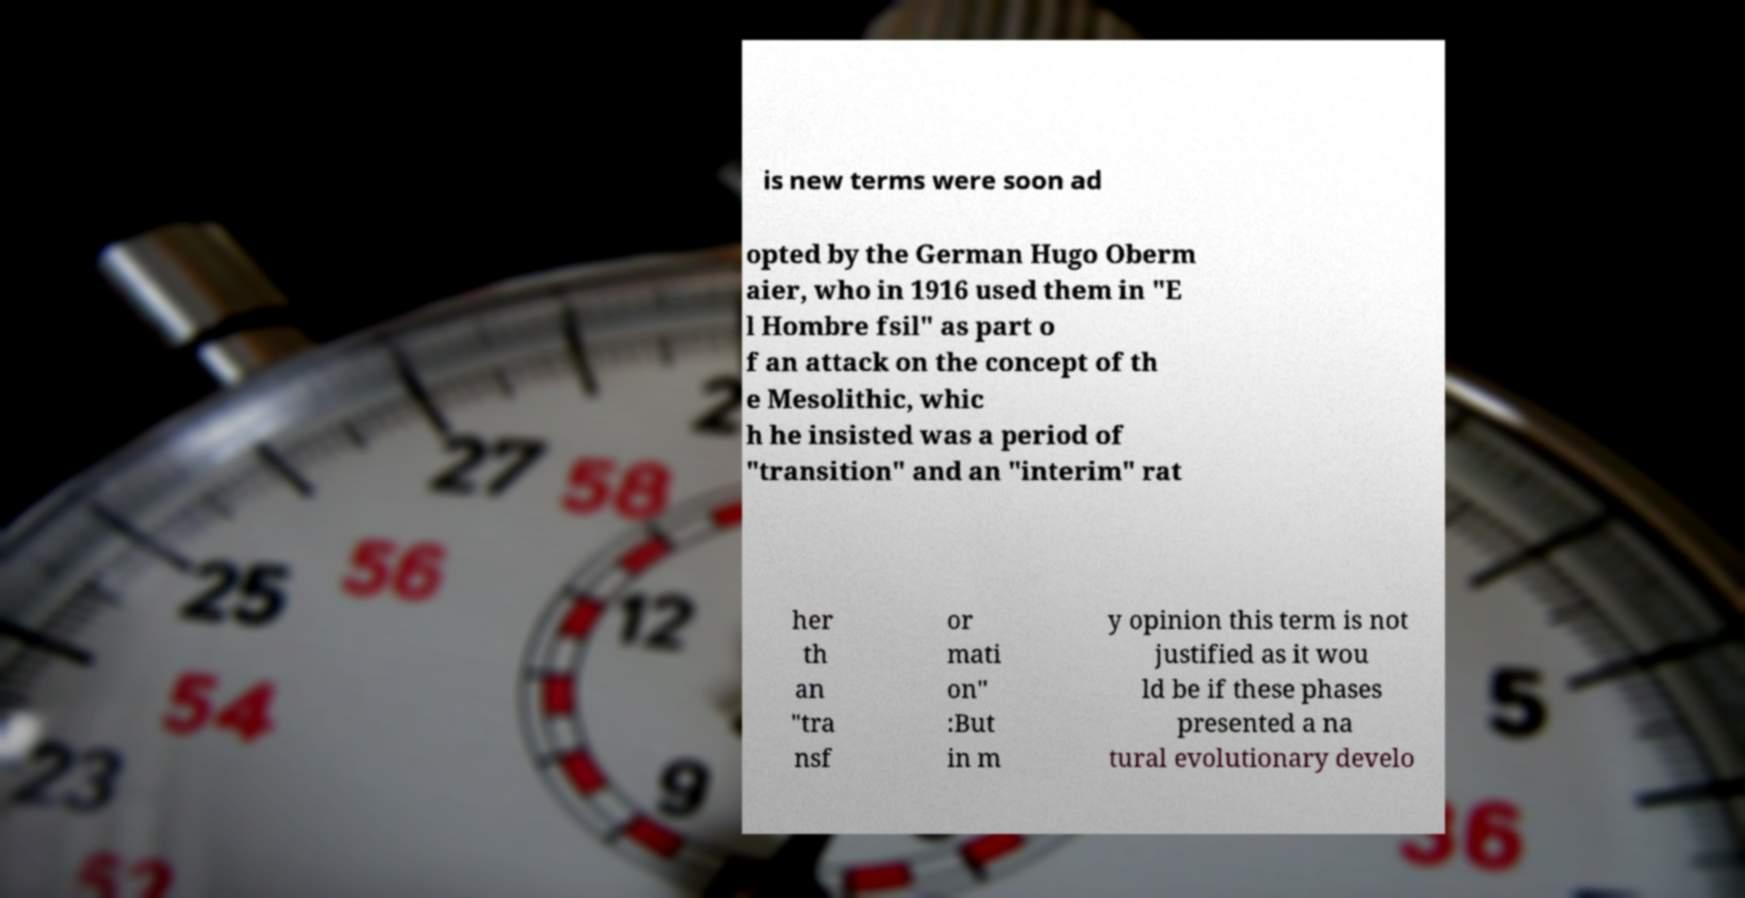What messages or text are displayed in this image? I need them in a readable, typed format. is new terms were soon ad opted by the German Hugo Oberm aier, who in 1916 used them in "E l Hombre fsil" as part o f an attack on the concept of th e Mesolithic, whic h he insisted was a period of "transition" and an "interim" rat her th an "tra nsf or mati on" :But in m y opinion this term is not justified as it wou ld be if these phases presented a na tural evolutionary develo 